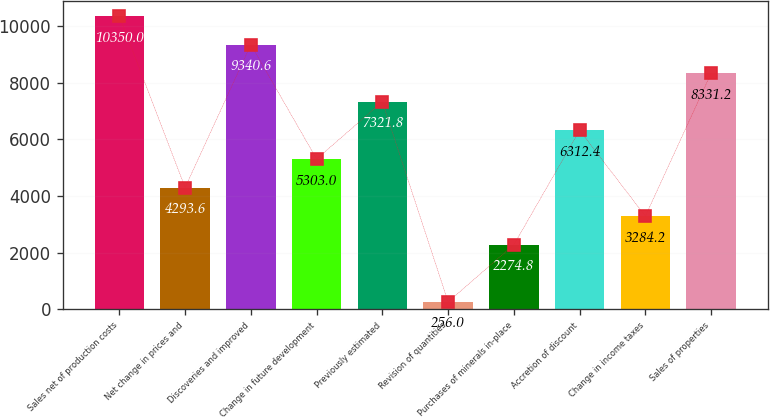Convert chart. <chart><loc_0><loc_0><loc_500><loc_500><bar_chart><fcel>Sales net of production costs<fcel>Net change in prices and<fcel>Discoveries and improved<fcel>Change in future development<fcel>Previously estimated<fcel>Revision of quantities<fcel>Purchases of minerals in-place<fcel>Accretion of discount<fcel>Change in income taxes<fcel>Sales of properties<nl><fcel>10350<fcel>4293.6<fcel>9340.6<fcel>5303<fcel>7321.8<fcel>256<fcel>2274.8<fcel>6312.4<fcel>3284.2<fcel>8331.2<nl></chart> 